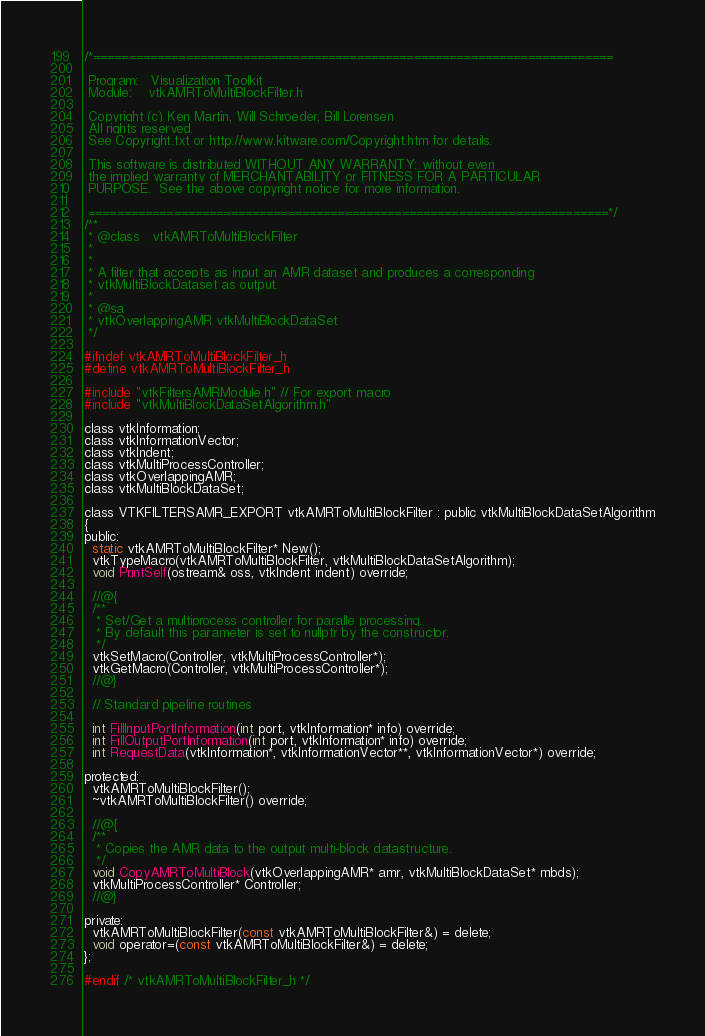<code> <loc_0><loc_0><loc_500><loc_500><_C_>/*=========================================================================

 Program:   Visualization Toolkit
 Module:    vtkAMRToMultiBlockFilter.h

 Copyright (c) Ken Martin, Will Schroeder, Bill Lorensen
 All rights reserved.
 See Copyright.txt or http://www.kitware.com/Copyright.htm for details.

 This software is distributed WITHOUT ANY WARRANTY; without even
 the implied warranty of MERCHANTABILITY or FITNESS FOR A PARTICULAR
 PURPOSE.  See the above copyright notice for more information.

 =========================================================================*/
/**
 * @class   vtkAMRToMultiBlockFilter
 *
 *
 * A filter that accepts as input an AMR dataset and produces a corresponding
 * vtkMultiBlockDataset as output.
 *
 * @sa
 * vtkOverlappingAMR vtkMultiBlockDataSet
 */

#ifndef vtkAMRToMultiBlockFilter_h
#define vtkAMRToMultiBlockFilter_h

#include "vtkFiltersAMRModule.h" // For export macro
#include "vtkMultiBlockDataSetAlgorithm.h"

class vtkInformation;
class vtkInformationVector;
class vtkIndent;
class vtkMultiProcessController;
class vtkOverlappingAMR;
class vtkMultiBlockDataSet;

class VTKFILTERSAMR_EXPORT vtkAMRToMultiBlockFilter : public vtkMultiBlockDataSetAlgorithm
{
public:
  static vtkAMRToMultiBlockFilter* New();
  vtkTypeMacro(vtkAMRToMultiBlockFilter, vtkMultiBlockDataSetAlgorithm);
  void PrintSelf(ostream& oss, vtkIndent indent) override;

  //@{
  /**
   * Set/Get a multiprocess controller for paralle processing.
   * By default this parameter is set to nullptr by the constructor.
   */
  vtkSetMacro(Controller, vtkMultiProcessController*);
  vtkGetMacro(Controller, vtkMultiProcessController*);
  //@}

  // Standard pipeline routines

  int FillInputPortInformation(int port, vtkInformation* info) override;
  int FillOutputPortInformation(int port, vtkInformation* info) override;
  int RequestData(vtkInformation*, vtkInformationVector**, vtkInformationVector*) override;

protected:
  vtkAMRToMultiBlockFilter();
  ~vtkAMRToMultiBlockFilter() override;

  //@{
  /**
   * Copies the AMR data to the output multi-block datastructure.
   */
  void CopyAMRToMultiBlock(vtkOverlappingAMR* amr, vtkMultiBlockDataSet* mbds);
  vtkMultiProcessController* Controller;
  //@}

private:
  vtkAMRToMultiBlockFilter(const vtkAMRToMultiBlockFilter&) = delete;
  void operator=(const vtkAMRToMultiBlockFilter&) = delete;
};

#endif /* vtkAMRToMultiBlockFilter_h */
</code> 